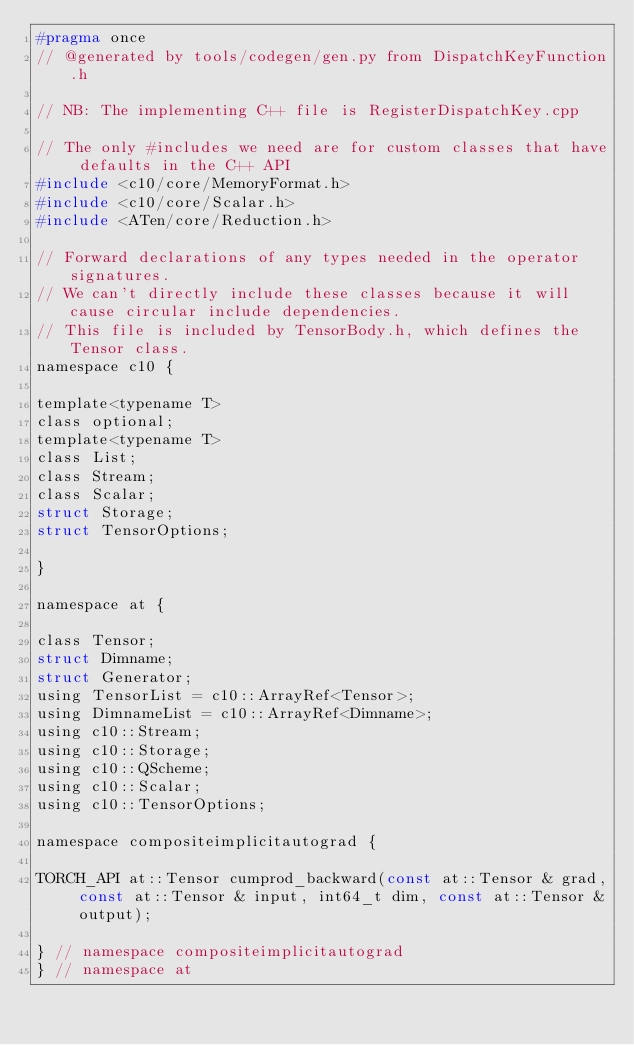Convert code to text. <code><loc_0><loc_0><loc_500><loc_500><_C_>#pragma once
// @generated by tools/codegen/gen.py from DispatchKeyFunction.h

// NB: The implementing C++ file is RegisterDispatchKey.cpp

// The only #includes we need are for custom classes that have defaults in the C++ API
#include <c10/core/MemoryFormat.h>
#include <c10/core/Scalar.h>
#include <ATen/core/Reduction.h>

// Forward declarations of any types needed in the operator signatures.
// We can't directly include these classes because it will cause circular include dependencies.
// This file is included by TensorBody.h, which defines the Tensor class.
namespace c10 {

template<typename T>
class optional;
template<typename T>
class List;
class Stream;
class Scalar;
struct Storage;
struct TensorOptions;

}

namespace at {

class Tensor;
struct Dimname;
struct Generator;
using TensorList = c10::ArrayRef<Tensor>;
using DimnameList = c10::ArrayRef<Dimname>;
using c10::Stream;
using c10::Storage;
using c10::QScheme;
using c10::Scalar;
using c10::TensorOptions;

namespace compositeimplicitautograd {

TORCH_API at::Tensor cumprod_backward(const at::Tensor & grad, const at::Tensor & input, int64_t dim, const at::Tensor & output);

} // namespace compositeimplicitautograd
} // namespace at
</code> 